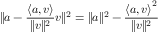<formula> <loc_0><loc_0><loc_500><loc_500>\| a - { \frac { \langle a , v \rangle } { \| v \| ^ { 2 } } } v \| ^ { 2 } = \| a \| ^ { 2 } - { \frac { { \langle a , v \rangle } ^ { 2 } } { \| v \| ^ { 2 } } }</formula> 